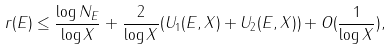Convert formula to latex. <formula><loc_0><loc_0><loc_500><loc_500>r ( E ) \leq \frac { \log N _ { E } } { \log X } + \frac { 2 } { \log X } ( U _ { 1 } ( E , X ) + U _ { 2 } ( E , X ) ) + O ( \frac { 1 } { \log X } ) ,</formula> 